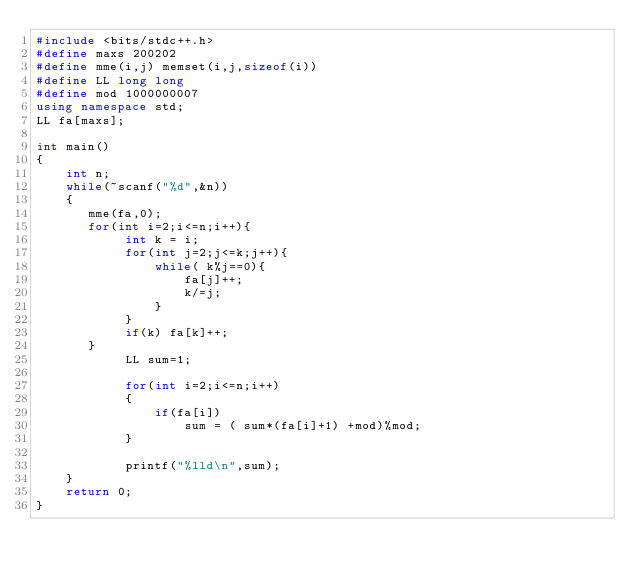<code> <loc_0><loc_0><loc_500><loc_500><_C++_>#include <bits/stdc++.h>
#define maxs 200202
#define mme(i,j) memset(i,j,sizeof(i))
#define LL long long
#define mod 1000000007
using namespace std;
LL fa[maxs];

int main()
{
    int n;
    while(~scanf("%d",&n))
    {
       mme(fa,0);
       for(int i=2;i<=n;i++){
            int k = i;
            for(int j=2;j<=k;j++){
                while( k%j==0){
                    fa[j]++;
                    k/=j;
                }
            }
            if(k) fa[k]++;
       }
            LL sum=1;

            for(int i=2;i<=n;i++)
            {
                if(fa[i])
                    sum = ( sum*(fa[i]+1) +mod)%mod;
            }

            printf("%lld\n",sum);
    }
    return 0;
}
</code> 